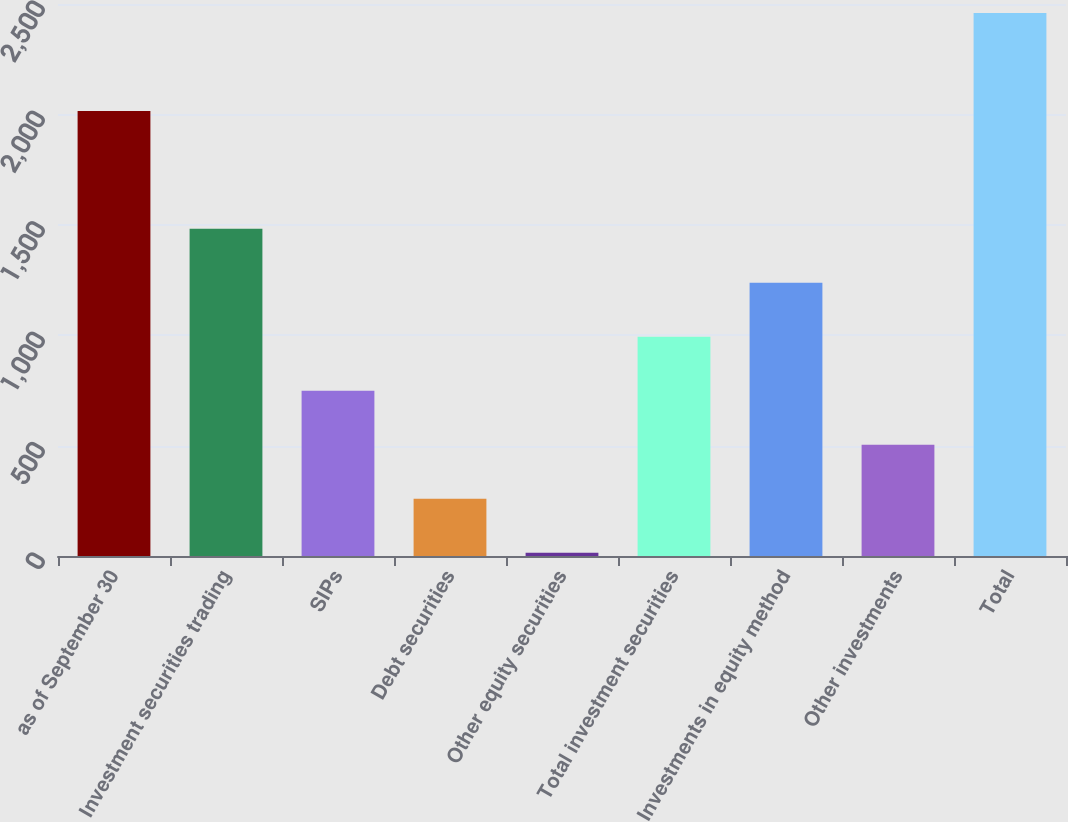Convert chart. <chart><loc_0><loc_0><loc_500><loc_500><bar_chart><fcel>as of September 30<fcel>Investment securities trading<fcel>SIPs<fcel>Debt securities<fcel>Other equity securities<fcel>Total investment securities<fcel>Investments in equity method<fcel>Other investments<fcel>Total<nl><fcel>2015<fcel>1481.56<fcel>748.33<fcel>259.51<fcel>15.1<fcel>992.74<fcel>1237.15<fcel>503.92<fcel>2459.2<nl></chart> 